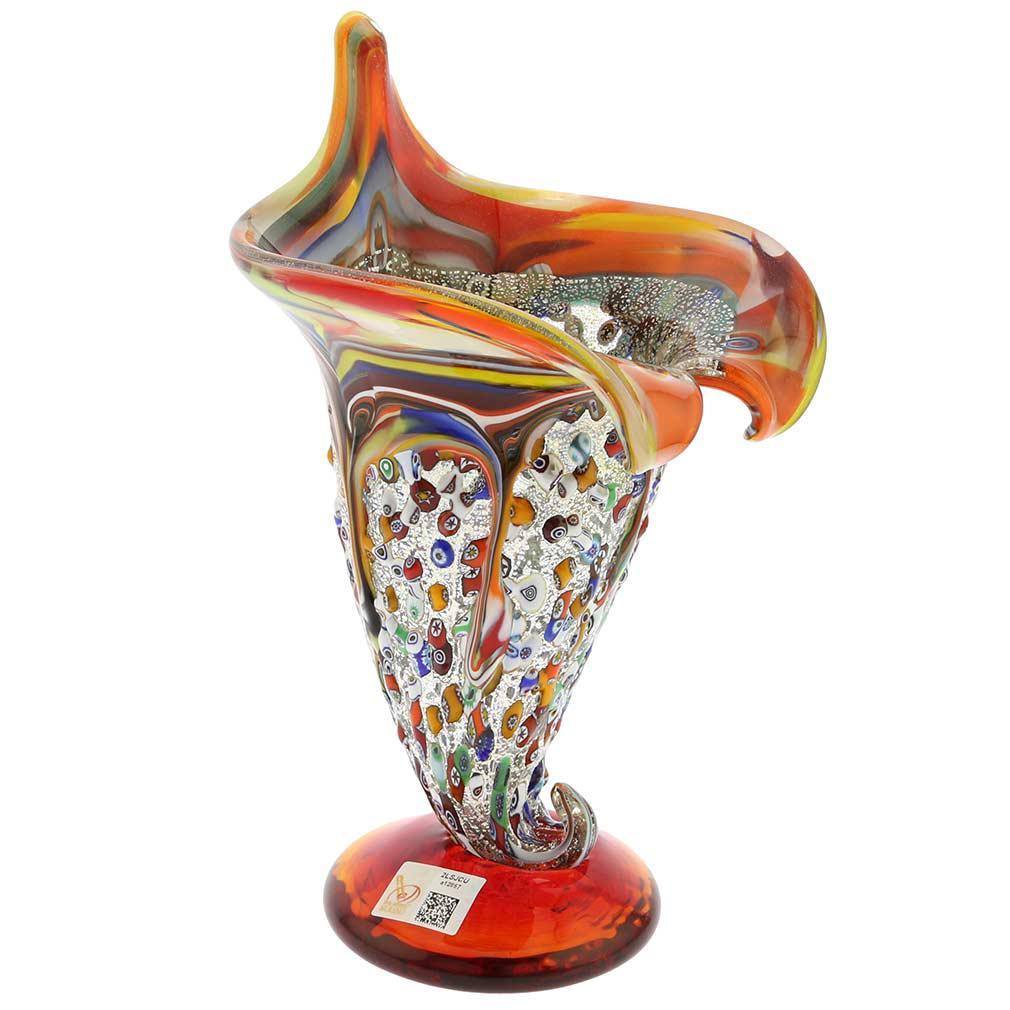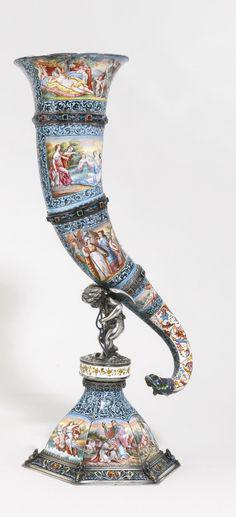The first image is the image on the left, the second image is the image on the right. Assess this claim about the two images: "The vase on the right has a curled bottom.". Correct or not? Answer yes or no. Yes. The first image is the image on the left, the second image is the image on the right. For the images shown, is this caption "The vases in the two images have the same shape and color." true? Answer yes or no. No. 